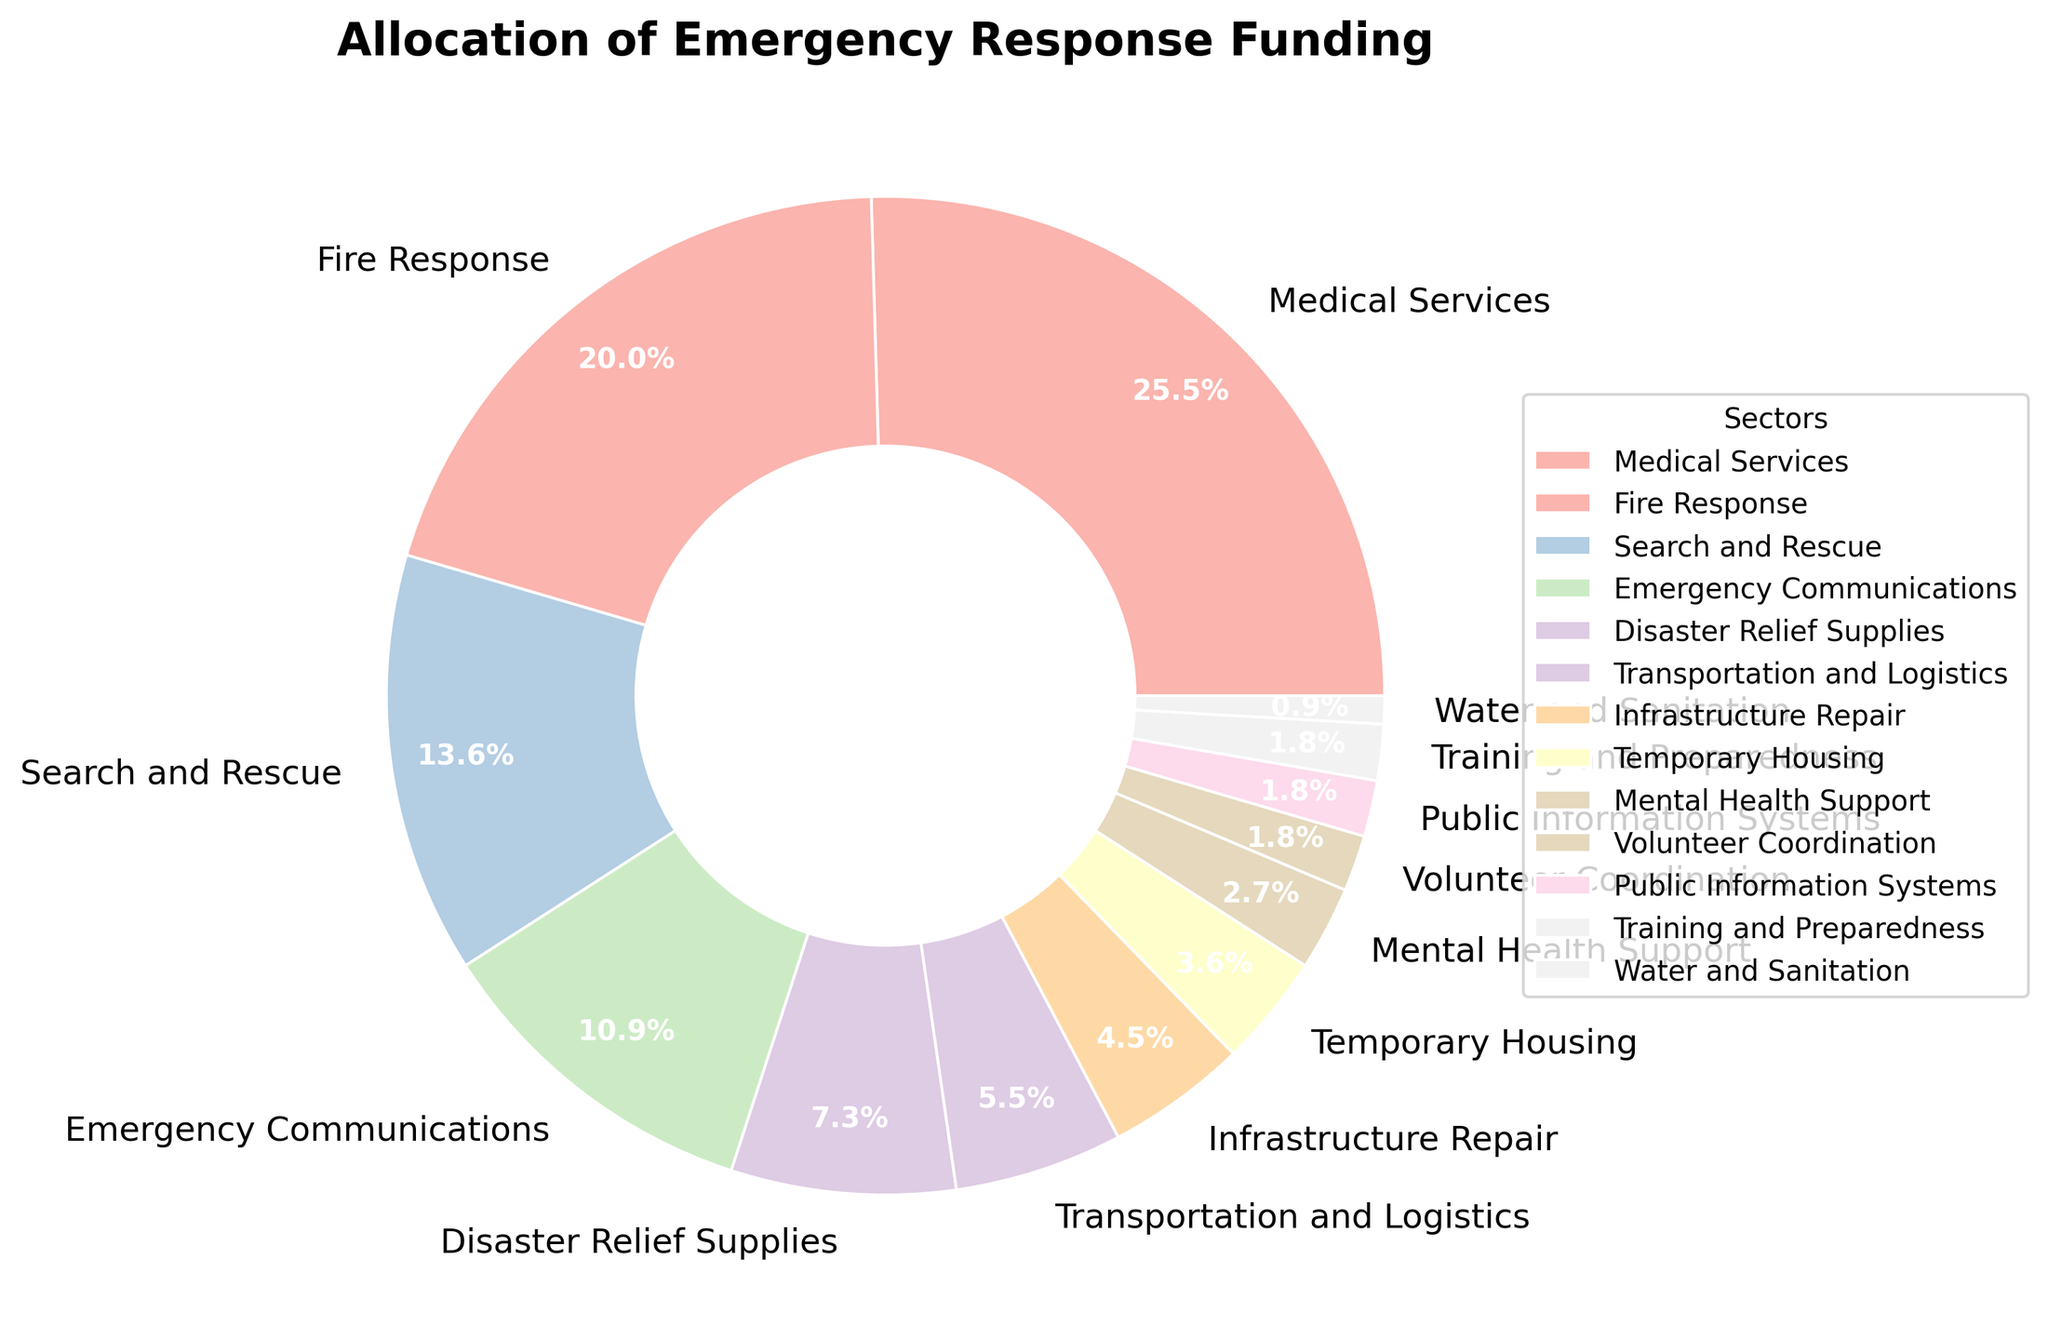What sector receives the highest percentage of funding? The sector with the largest slice of the pie chart is the one that receives the highest percentage of funding.
Answer: Medical Services How much more funding percentage does Medical Services get compared to Fire Response? Medical Services has 28% and Fire Response has 22%. The difference is 28 - 22 = 6%.
Answer: 6% Which sectors receive less than 3% of the total funding? Identify the sectors with slices labeled with percentages less than 3%. These sectors are Volunteer Coordination, Public Information Systems, Training and Preparedness, and Water and Sanitation.
Answer: Volunteer Coordination, Public Information Systems, Training and Preparedness, Water and Sanitation What is the combined funding percentage for Search and Rescue and Emergency Communications? Add the funding percentages of both sectors: 15% (Search and Rescue) + 12% (Emergency Communications) = 27%.
Answer: 27% Out of Disaster Relief Supplies and Transportation and Logistics, which sector gets more funding? Compare the slices labeled for each sector. Disaster Relief Supplies has 8%, and Transportation and Logistics has 6%, so Disaster Relief Supplies gets more funding.
Answer: Disaster Relief Supplies What percentage of funding is allocated to sectors receiving 5% or less? Sum the percentages of sectors receiving 5% or less: Infrastructure Repair (5%) + Temporary Housing (4%) + Mental Health Support (3%) + Volunteer Coordination (2%) + Public Information Systems (2%) + Training and Preparedness (2%) + Water and Sanitation (1%) = 5+4+3+2+2+2+1 = 19%.
Answer: 19% Are there any sectors that receive the same percentage of funding? If so, which ones? Identify sectors with equal-sized slices and labeled with the same percentage. Public Information Systems, Training and Preparedness, and Volunteer Coordination each receive 2%.
Answer: Public Information Systems, Training and Preparedness, Volunteer Coordination What is the average funding percentage for Fire Response, Search and Rescue, and Temporary Housing? Calculate the sum of percentages: Fire Response (22%) + Search and Rescue (15%) + Temporary Housing (4%) = 22 + 15 + 4 = 41. Then divide by the number of sectors: 41 / 3 = 13.67%.
Answer: 13.67% 